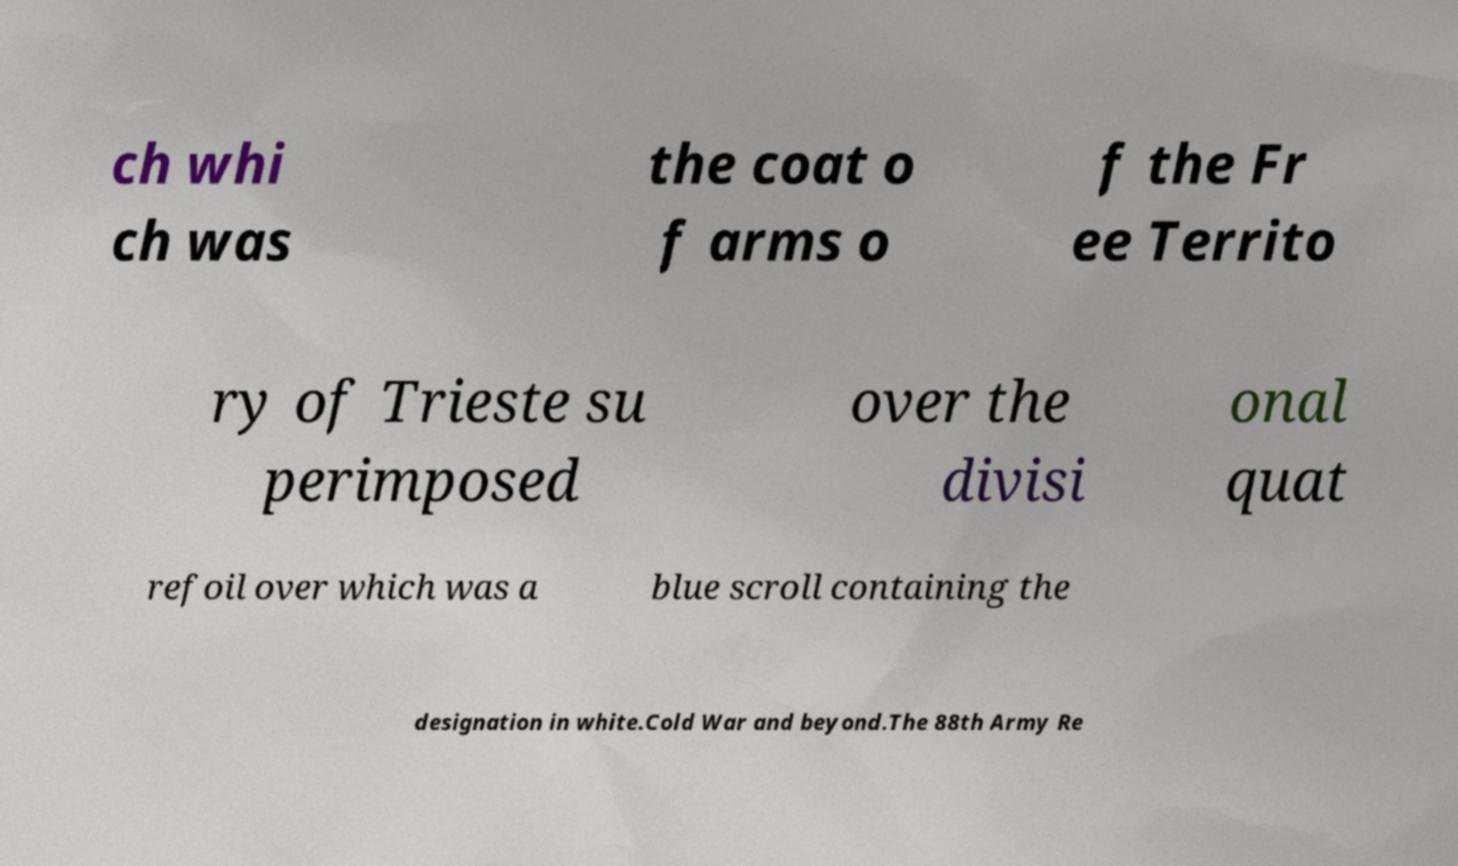Could you assist in decoding the text presented in this image and type it out clearly? ch whi ch was the coat o f arms o f the Fr ee Territo ry of Trieste su perimposed over the divisi onal quat refoil over which was a blue scroll containing the designation in white.Cold War and beyond.The 88th Army Re 